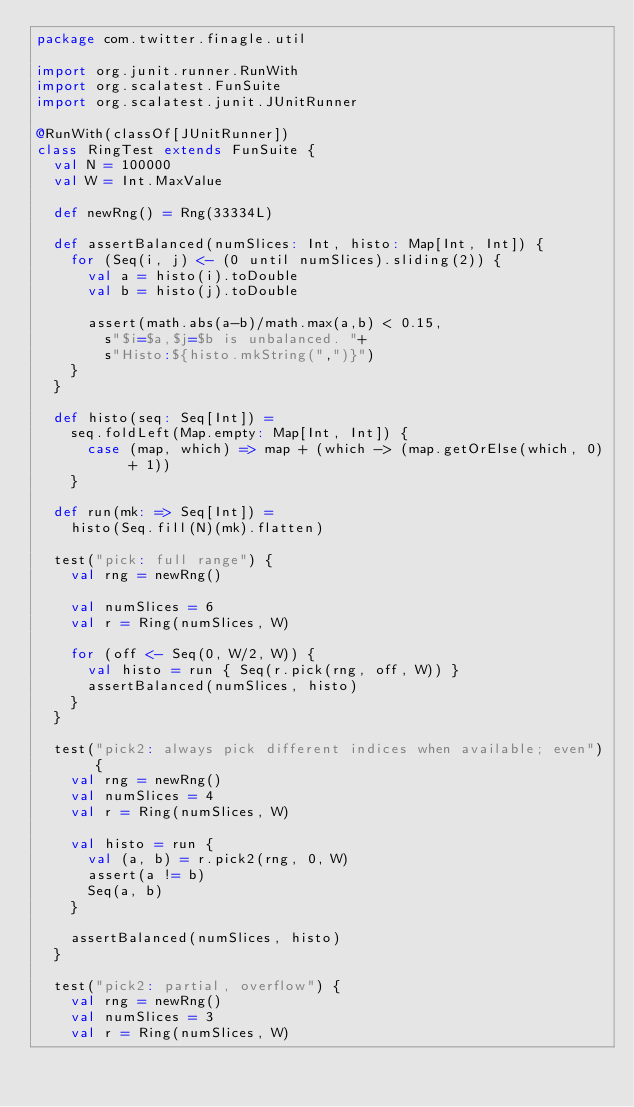<code> <loc_0><loc_0><loc_500><loc_500><_Scala_>package com.twitter.finagle.util

import org.junit.runner.RunWith
import org.scalatest.FunSuite
import org.scalatest.junit.JUnitRunner

@RunWith(classOf[JUnitRunner])
class RingTest extends FunSuite {
  val N = 100000
  val W = Int.MaxValue

  def newRng() = Rng(33334L)

  def assertBalanced(numSlices: Int, histo: Map[Int, Int]) {
    for (Seq(i, j) <- (0 until numSlices).sliding(2)) {
      val a = histo(i).toDouble
      val b = histo(j).toDouble

      assert(math.abs(a-b)/math.max(a,b) < 0.15,
        s"$i=$a,$j=$b is unbalanced. "+
        s"Histo:${histo.mkString(",")}")
    }
  }

  def histo(seq: Seq[Int]) =
    seq.foldLeft(Map.empty: Map[Int, Int]) {
      case (map, which) => map + (which -> (map.getOrElse(which, 0) + 1))
    }

  def run(mk: => Seq[Int]) =
    histo(Seq.fill(N)(mk).flatten)

  test("pick: full range") {
    val rng = newRng()

    val numSlices = 6
    val r = Ring(numSlices, W)

    for (off <- Seq(0, W/2, W)) {
      val histo = run { Seq(r.pick(rng, off, W)) }
      assertBalanced(numSlices, histo)
    }
  }

  test("pick2: always pick different indices when available; even") {
    val rng = newRng()
    val numSlices = 4
    val r = Ring(numSlices, W)

    val histo = run {
      val (a, b) = r.pick2(rng, 0, W)
      assert(a != b)
      Seq(a, b)
    }

    assertBalanced(numSlices, histo)
  }

  test("pick2: partial, overflow") {
    val rng = newRng()
    val numSlices = 3
    val r = Ring(numSlices, W)</code> 